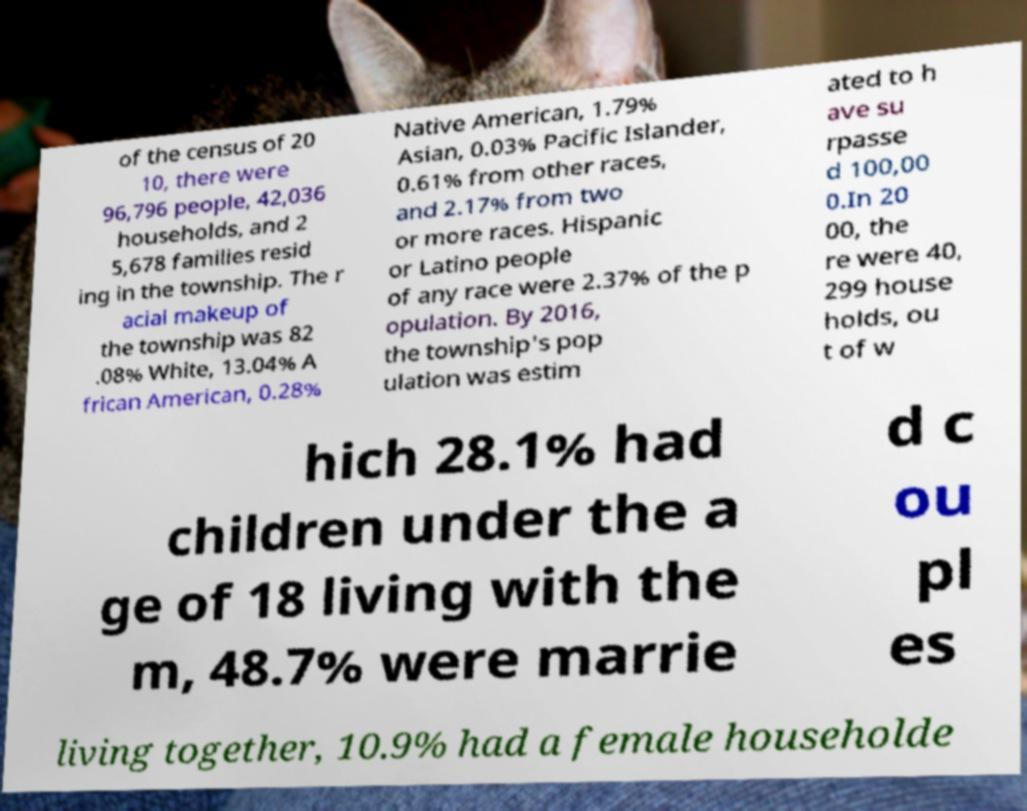Can you read and provide the text displayed in the image?This photo seems to have some interesting text. Can you extract and type it out for me? of the census of 20 10, there were 96,796 people, 42,036 households, and 2 5,678 families resid ing in the township. The r acial makeup of the township was 82 .08% White, 13.04% A frican American, 0.28% Native American, 1.79% Asian, 0.03% Pacific Islander, 0.61% from other races, and 2.17% from two or more races. Hispanic or Latino people of any race were 2.37% of the p opulation. By 2016, the township's pop ulation was estim ated to h ave su rpasse d 100,00 0.In 20 00, the re were 40, 299 house holds, ou t of w hich 28.1% had children under the a ge of 18 living with the m, 48.7% were marrie d c ou pl es living together, 10.9% had a female householde 